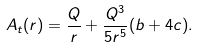Convert formula to latex. <formula><loc_0><loc_0><loc_500><loc_500>A _ { t } ( r ) = \frac { Q } { r } + \frac { Q ^ { 3 } } { 5 r ^ { 5 } } ( b + 4 c ) . \label a { A _ { t } ( r ) }</formula> 